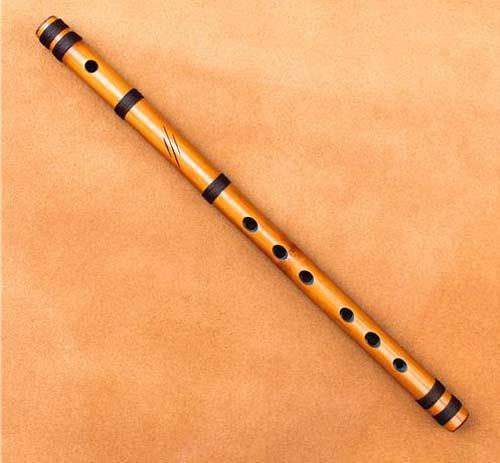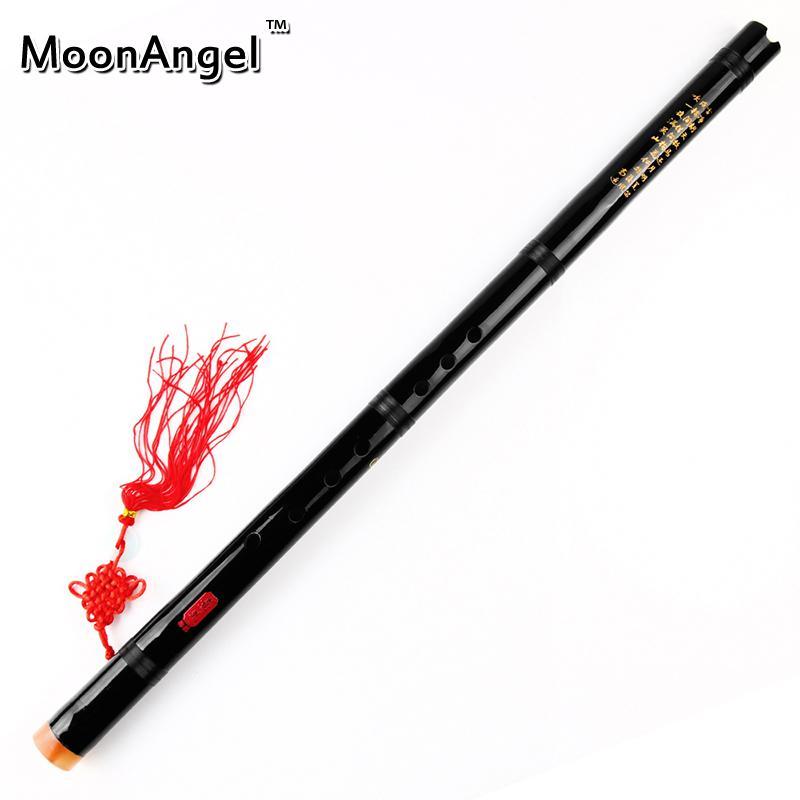The first image is the image on the left, the second image is the image on the right. Assess this claim about the two images: "A red tassel is connected to a straight flute.". Correct or not? Answer yes or no. Yes. The first image is the image on the left, the second image is the image on the right. Given the left and right images, does the statement "One image shows a diagonally displayed, perforated stick-shaped instrument with a red tassel at its lower end, and the other image shows a similar gold and black instrument with no tassel." hold true? Answer yes or no. Yes. 